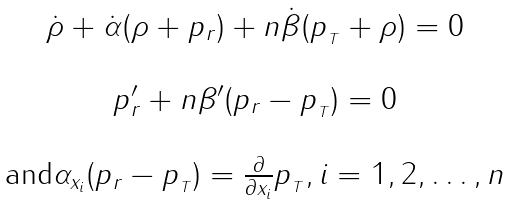Convert formula to latex. <formula><loc_0><loc_0><loc_500><loc_500>\begin{array} { c } \dot { \rho } + \dot { \alpha } ( \rho + p _ { r } ) + n \dot { \beta } ( p _ { _ { T } } + \rho ) = 0 \\ \\ p _ { r } ^ { \prime } + n \beta ^ { \prime } ( p _ { r } - p _ { _ { T } } ) = 0 \\ \\ \text {and} \alpha _ { x _ { i } } ( p _ { r } - p _ { _ { T } } ) = \frac { \partial } { \partial x _ { i } } p _ { _ { T } } , i = 1 , 2 , \dots , n \end{array}</formula> 